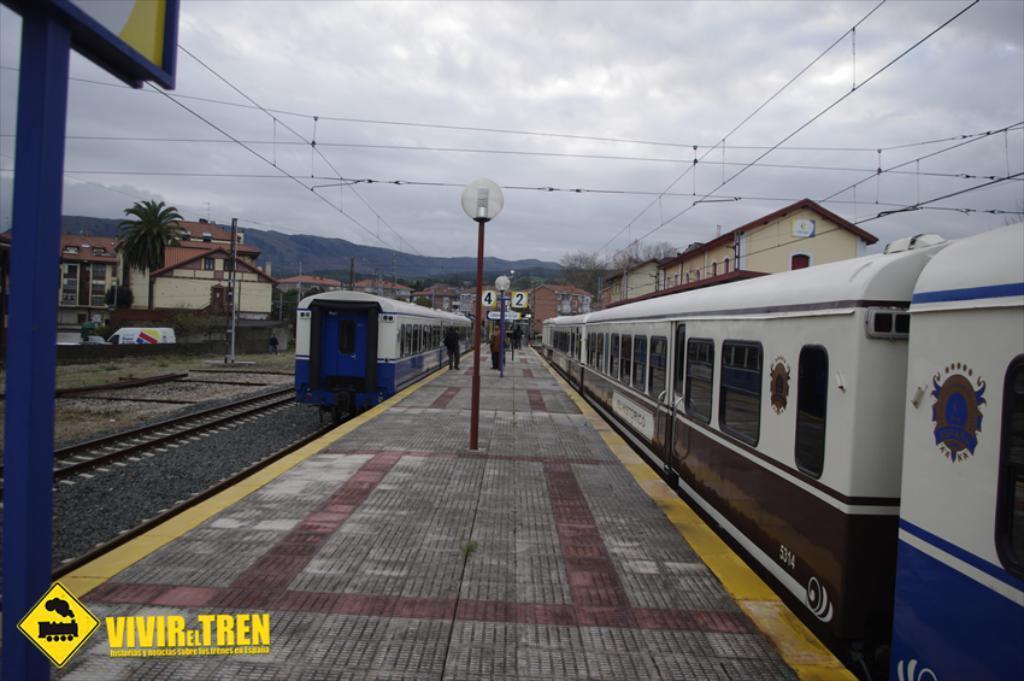Could you give a brief overview of what you see in this image? This picture might be taken in a railway station, in this image in the center there are two trains. At the bottom there is a railway track, footpath and in the center there are some people walking on a footpath and there is one pole and light. And in the background there are some buildings, trees, mountains and some wires. On the left side there is one hoarding, and at the top of the image there is sky. 